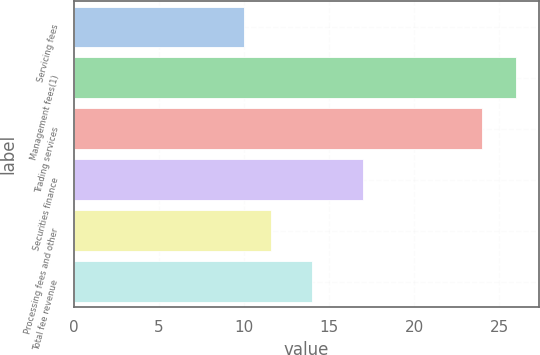Convert chart to OTSL. <chart><loc_0><loc_0><loc_500><loc_500><bar_chart><fcel>Servicing fees<fcel>Management fees(1)<fcel>Trading services<fcel>Securities finance<fcel>Processing fees and other<fcel>Total fee revenue<nl><fcel>10<fcel>26<fcel>24<fcel>17<fcel>11.6<fcel>14<nl></chart> 